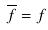Convert formula to latex. <formula><loc_0><loc_0><loc_500><loc_500>\overline { f } = f</formula> 